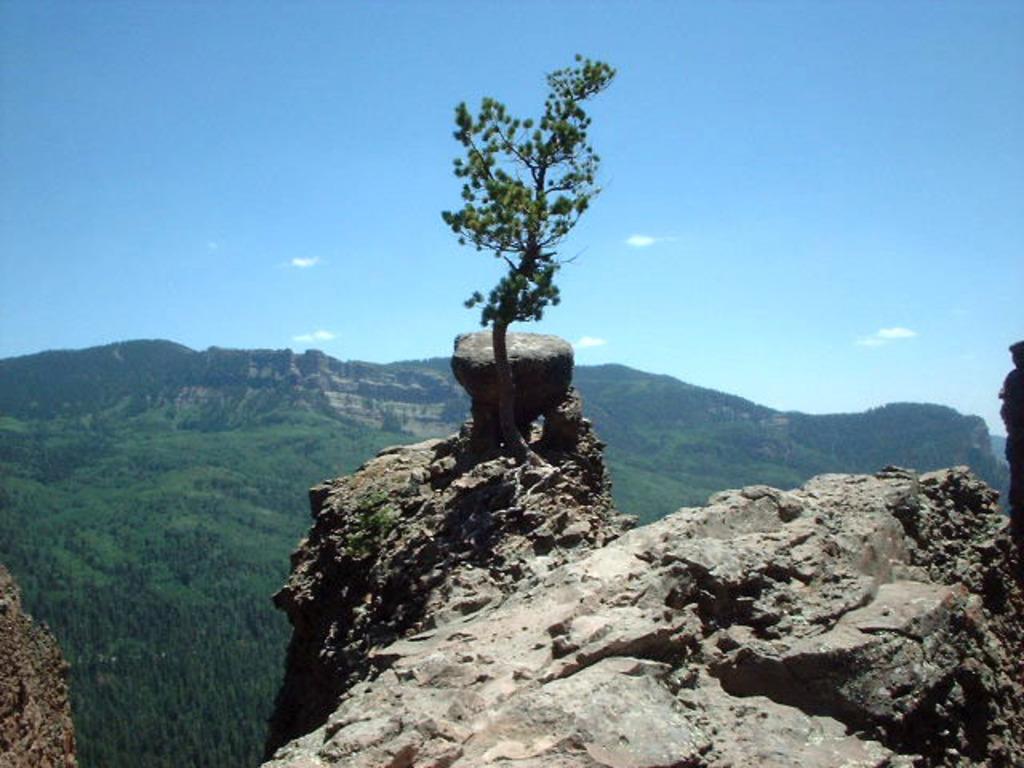How would you summarize this image in a sentence or two? In this image we can see some plants and stones on the hills. On the backside we can see a group of trees, the mountains and the sky which looks cloudy. 